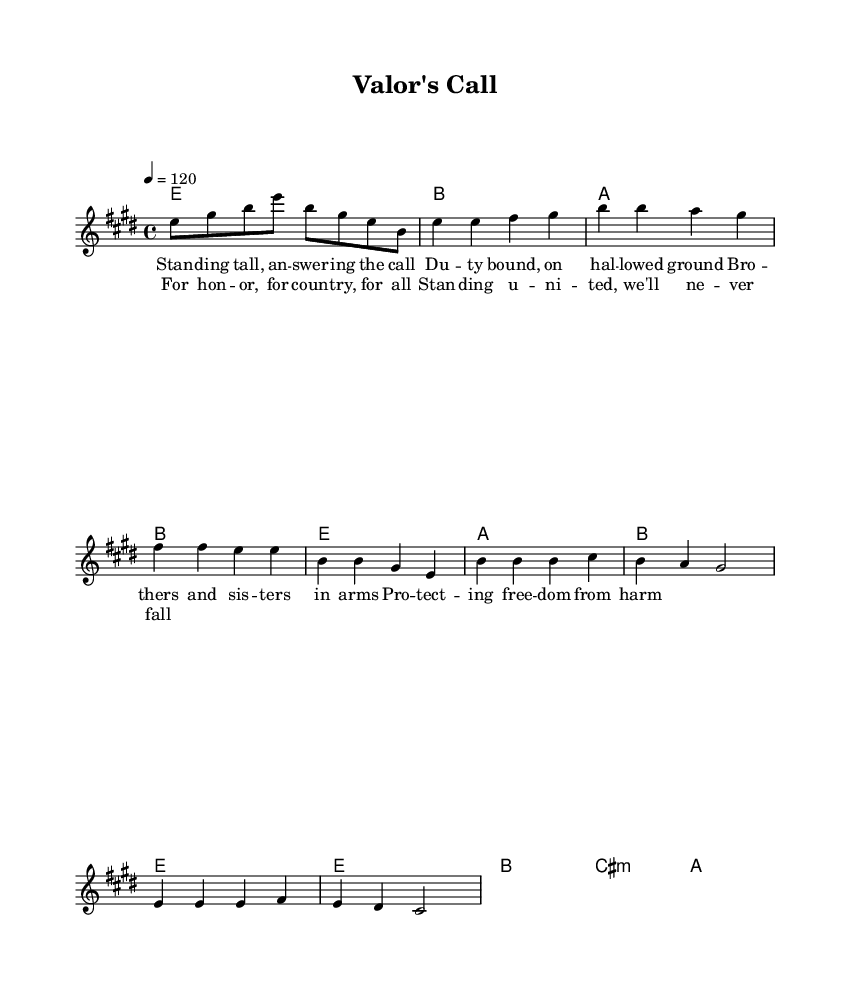What is the key signature of this music? The key signature is E major, which has four sharps (F#, C#, G#, D#). This is noted at the beginning of the staff before the first note.
Answer: E major What is the time signature of this composition? The time signature is 4/4, which indicates there are four quarter-note beats in each measure. This is shown at the beginning of the score next to the key signature.
Answer: 4/4 What is the tempo marking for the music? The tempo marking is quarter note equals 120, indicating the speed of the piece. This is indicated in the global section at the beginning of the score.
Answer: 120 How many verses are there in the song? There is one verse, which consists of lyrics set to the melody in the score. The lyrics are specifically indicated by the lyric mode section with the heading "verse."
Answer: One What is the primary theme of the song based on the lyrics? The primary theme of the song is honoring military service and sacrifice, as the lyrics speak about duty, protection, and standing united. The lyrics emphasize a commitment to honor and country.
Answer: Honor and sacrifice What is the first note of the melody? The first note of the melody is E, which can be identified in the melody section where the notes begin with "e8." This indicates that E is the starting pitch of the piece.
Answer: E Which chord is played during the chorus when the lyrics mention honor? The chord played during the chorus is B major, as seen in the harmonies section where B is listed in the chord sequence. This occurs during the lyrics that invoke the theme of honor.
Answer: B 